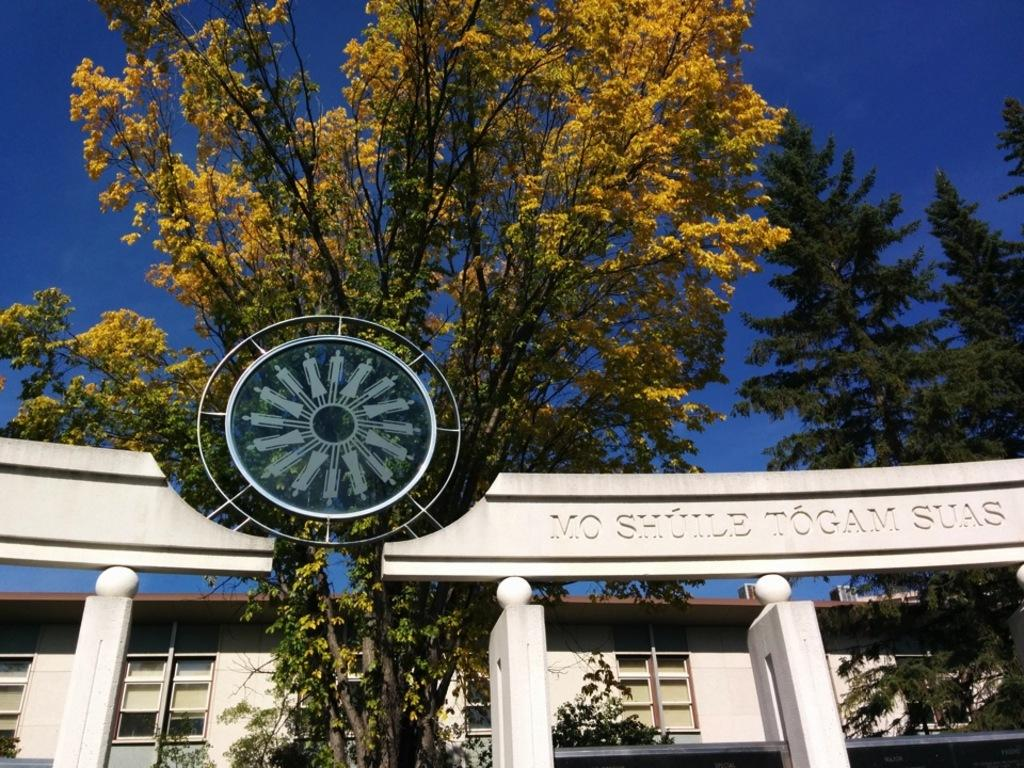What is the color of the building in the image? The building in the image is white-colored. What other elements can be seen in the image besides the building? There are trees and the sky visible in the image. What might be used for communication or identification in the image? There is text or writing present in the image. Can you see a person using a whip in the image? No, there is no person or whip present in the image. 